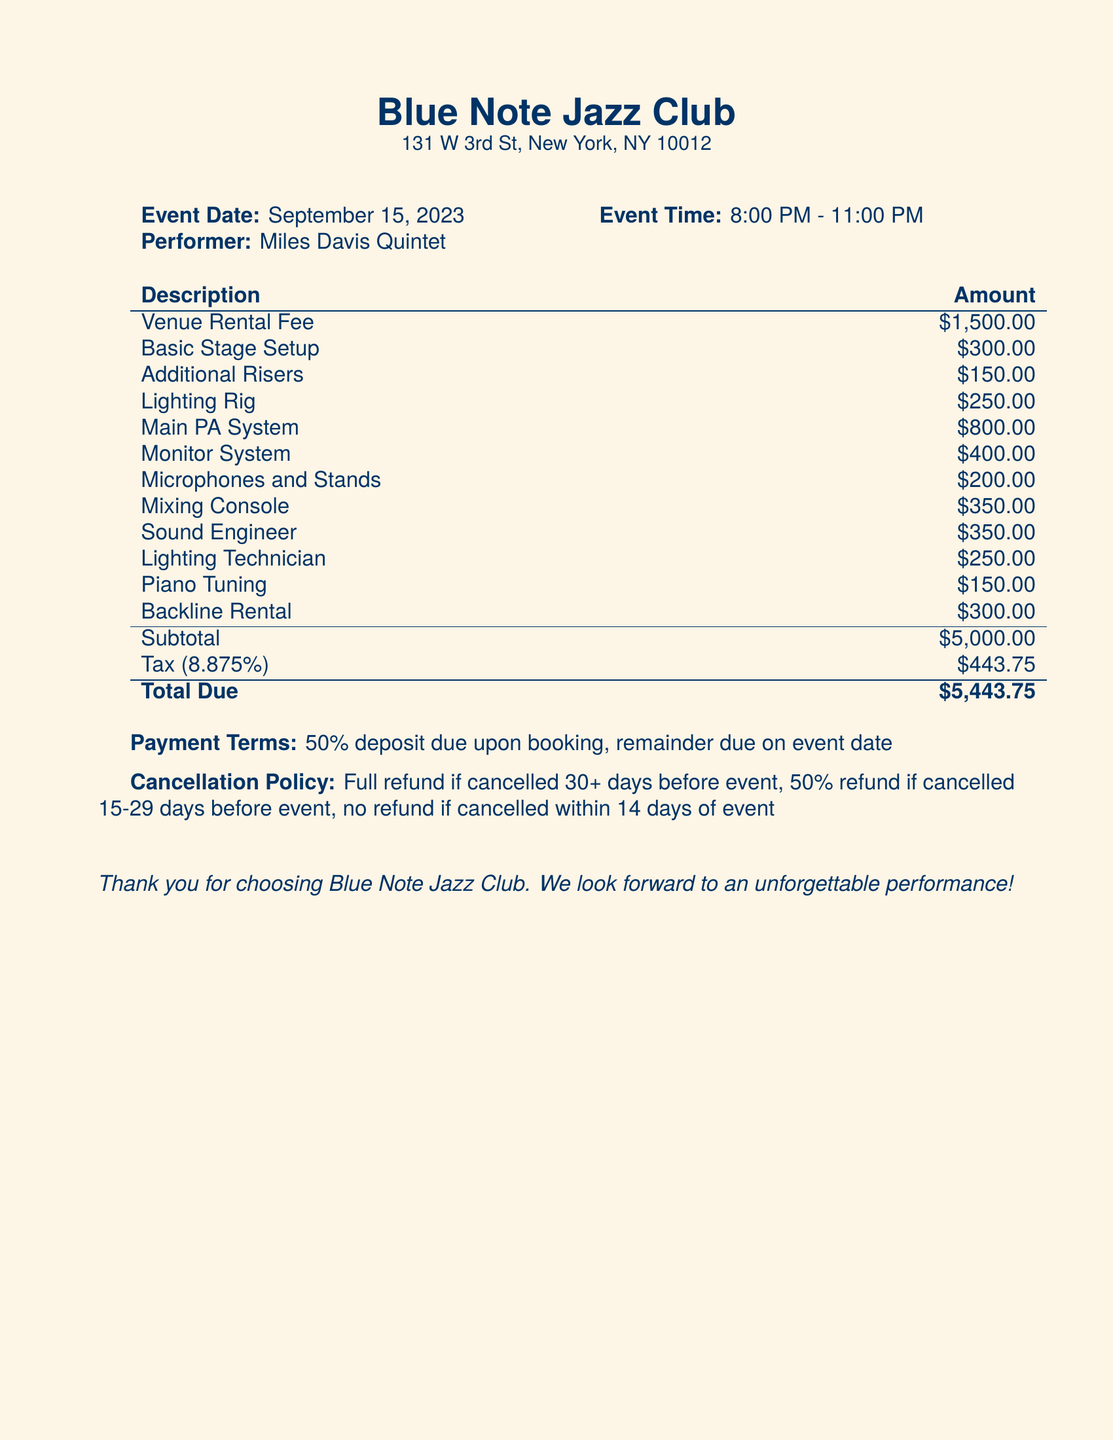What is the event date? The event date is specifically mentioned in the document under "Event Date," which states "September 15, 2023."
Answer: September 15, 2023 Who is the performer? The performer is listed in the document as "Miles Davis Quintet."
Answer: Miles Davis Quintet What is the total amount due? The total amount due is highlighted at the end of the bill under "Total Due," which is "$5,443.75."
Answer: $5,443.75 What percentage is the tax applied? The tax percentage is given in the document as "8.875%."
Answer: 8.875% What is included in the venue rental fee? The venue rental fee of $1,500.00 is listed separately but does not detail what it includes; it's the nominal fee associated with using the venue.
Answer: $1,500.00 How much is the fee for the sound engineer? The fee for hiring the sound engineer is explicitly stated as "$350.00" in the breakdown.
Answer: $350.00 What is the cancellation policy for an event? The cancellation policy details are outlined clearly in the document, indicating refunds based on the days prior to the event.
Answer: Full refund if canceled 30+ days before event What is the payment term? The payment term is provided under "Payment Terms," stating that a 50% deposit is required upon booking.
Answer: 50% deposit due upon booking How much does the piano tuning cost? The cost for piano tuning is listed under the description of services as "$150.00."
Answer: $150.00 